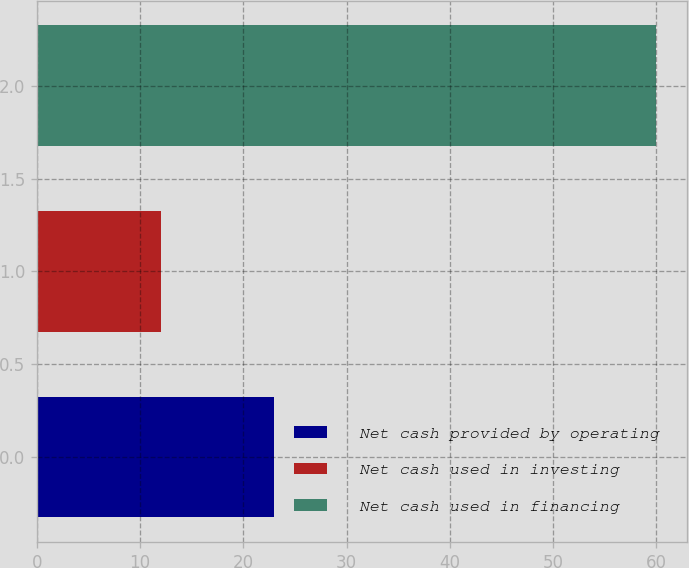Convert chart to OTSL. <chart><loc_0><loc_0><loc_500><loc_500><bar_chart><fcel>Net cash provided by operating<fcel>Net cash used in investing<fcel>Net cash used in financing<nl><fcel>23<fcel>12<fcel>60<nl></chart> 